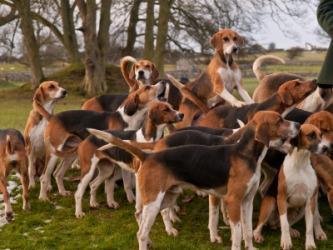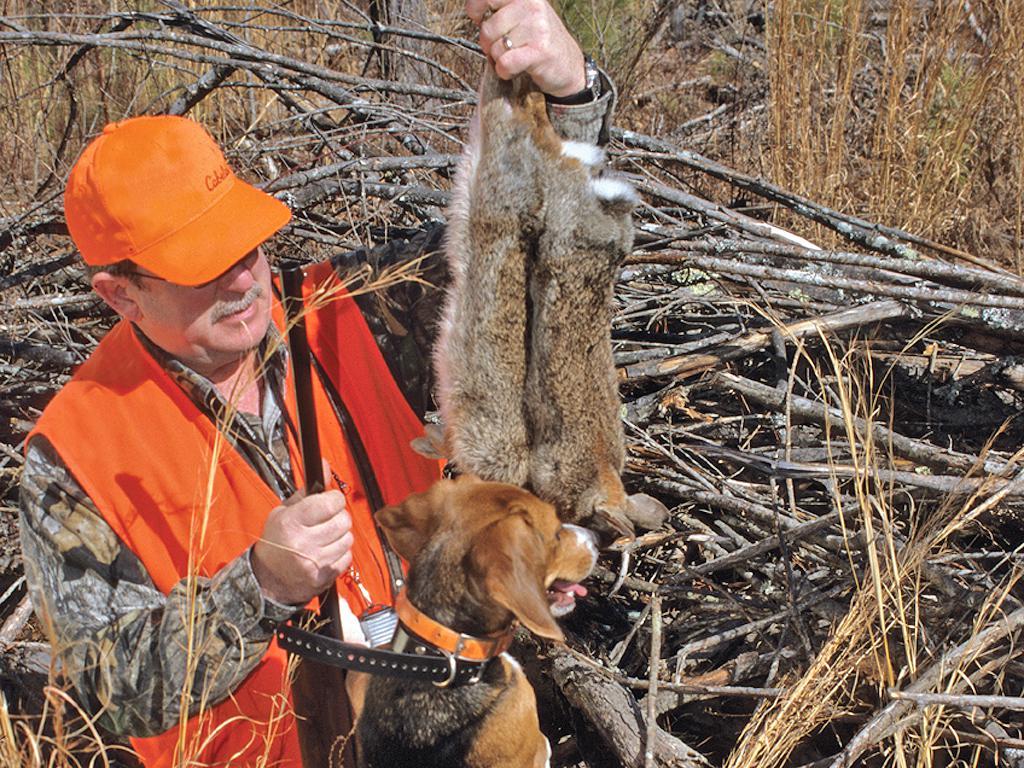The first image is the image on the left, the second image is the image on the right. For the images displayed, is the sentence "In at least one of the images, a hunter in a bright orange vest and hat holds a dead animal over a beagle" factually correct? Answer yes or no. Yes. The first image is the image on the left, the second image is the image on the right. Given the left and right images, does the statement "At least one image shows a man in orange vest and cap holding up a prey animal over a hound dog." hold true? Answer yes or no. Yes. 